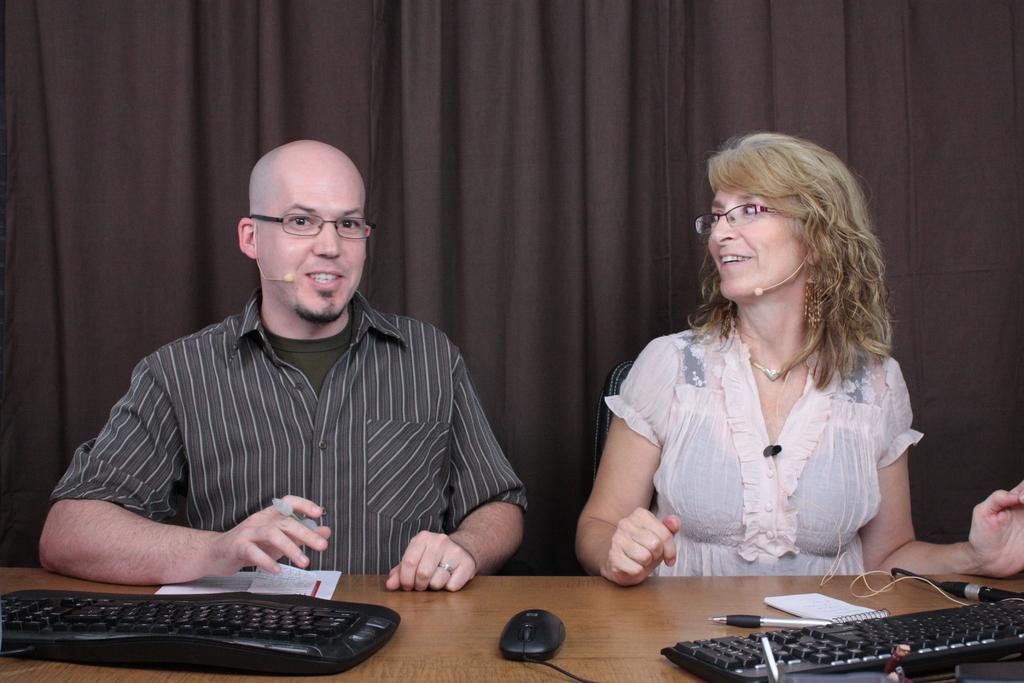Please provide a concise description of this image. In the foreground of this image, there is a man and a woman sitting near a table on which, keyboards, mouses, pen, papers and a mic are placed on it. In the background, there is a black curtain. 